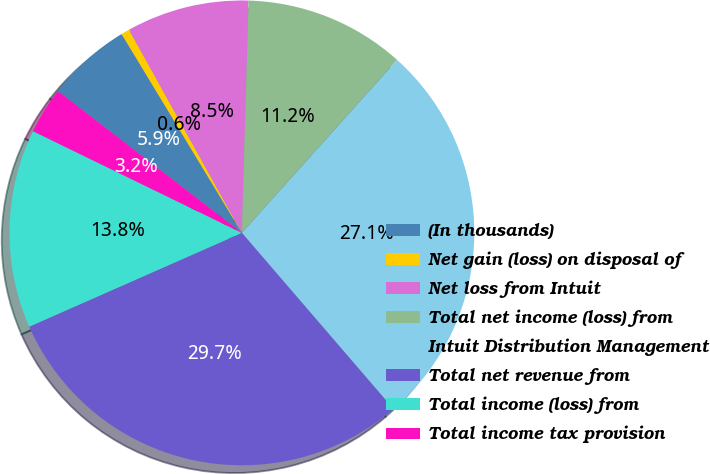<chart> <loc_0><loc_0><loc_500><loc_500><pie_chart><fcel>(In thousands)<fcel>Net gain (loss) on disposal of<fcel>Net loss from Intuit<fcel>Total net income (loss) from<fcel>Intuit Distribution Management<fcel>Total net revenue from<fcel>Total income (loss) from<fcel>Total income tax provision<nl><fcel>5.89%<fcel>0.59%<fcel>8.53%<fcel>11.18%<fcel>27.05%<fcel>29.7%<fcel>13.82%<fcel>3.24%<nl></chart> 